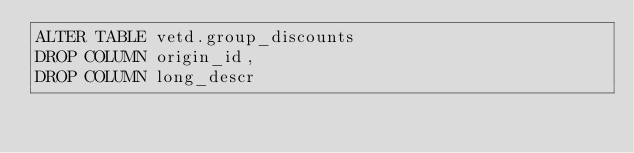<code> <loc_0><loc_0><loc_500><loc_500><_SQL_>ALTER TABLE vetd.group_discounts 
DROP COLUMN origin_id,
DROP COLUMN long_descr</code> 